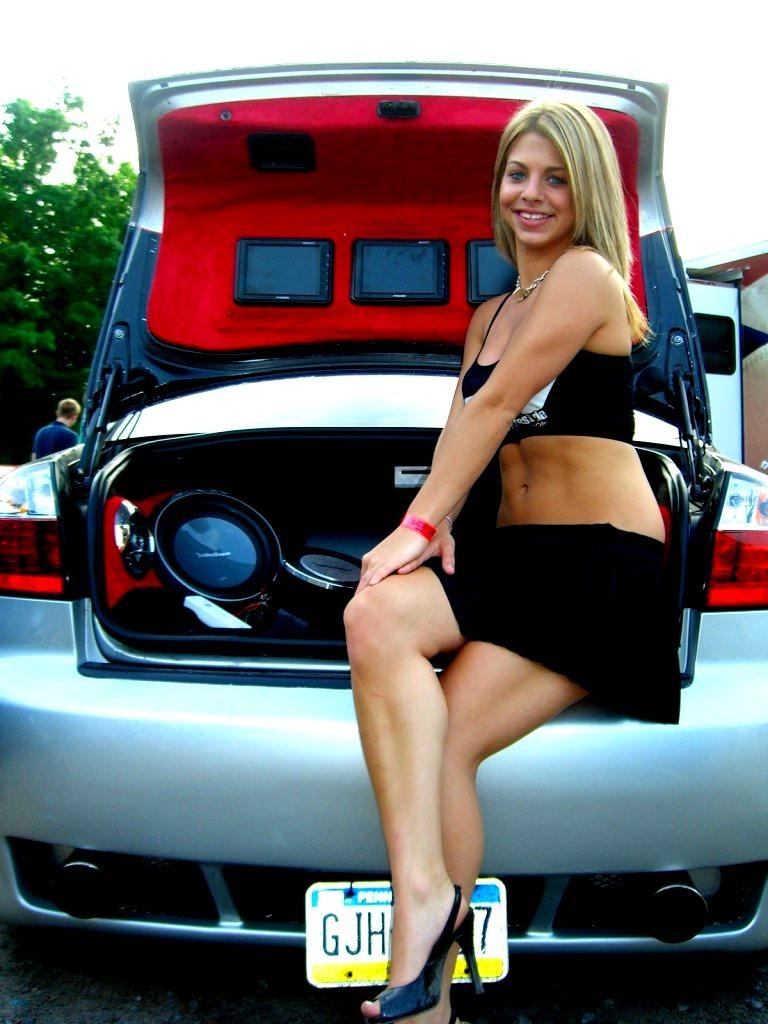What is the woman doing in the image? The woman is sitting on a car. What is the woman's facial expression in the image? The woman is smiling. What can be seen in the background of the image? There is a tree and sky visible in the background of the image. Are there any other people in the image besides the woman? Yes, there is a man in the background of the image. What type of cork is being used to hold the jar in the image? There is no jar or cork present in the image. How does the hill affect the woman's position on the car in the image? There is no hill present in the image, so it does not affect the woman's position on the car. 